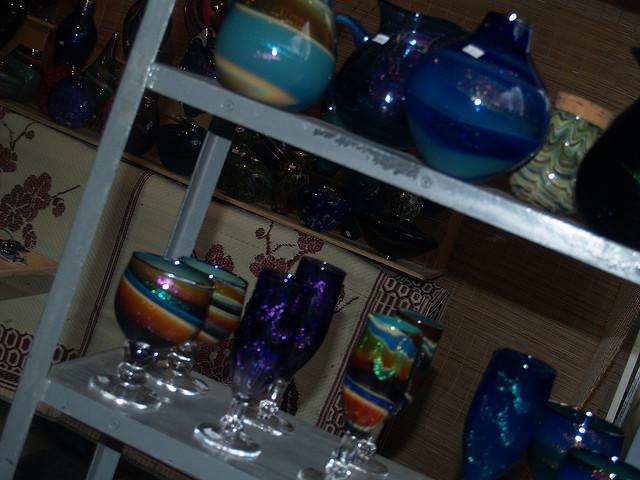Is this asian art?
Write a very short answer. No. What material is the shelf made of?
Write a very short answer. Metal. What kind of flowers are show?
Write a very short answer. None. Is the front shelf a new item or a used item?
Be succinct. New. 